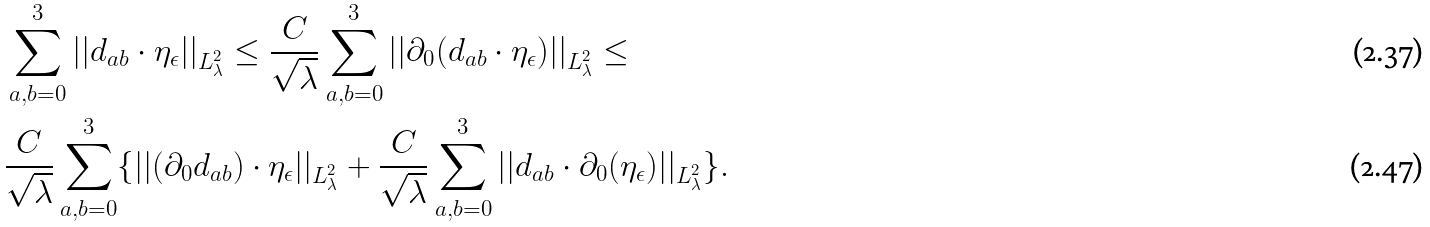Convert formula to latex. <formula><loc_0><loc_0><loc_500><loc_500>& \sum _ { a , b = 0 } ^ { 3 } | | d _ { a b } \cdot \eta _ { \epsilon } | | _ { L ^ { 2 } _ { \lambda } } \leq \frac { C } { \sqrt { \lambda } } \sum _ { a , b = 0 } ^ { 3 } | | \partial _ { 0 } ( d _ { a b } \cdot \eta _ { \epsilon } ) | | _ { L ^ { 2 } _ { \lambda } } \leq \\ & \frac { C } { \sqrt { \lambda } } \sum _ { a , b = 0 } ^ { 3 } \{ | | ( \partial _ { 0 } d _ { a b } ) \cdot \eta _ { \epsilon } | | _ { L ^ { 2 } _ { \lambda } } + \frac { C } { \sqrt { \lambda } } \sum _ { a , b = 0 } ^ { 3 } | | d _ { a b } \cdot \partial _ { 0 } ( \eta _ { \epsilon } ) | | _ { L ^ { 2 } _ { \lambda } } \} .</formula> 